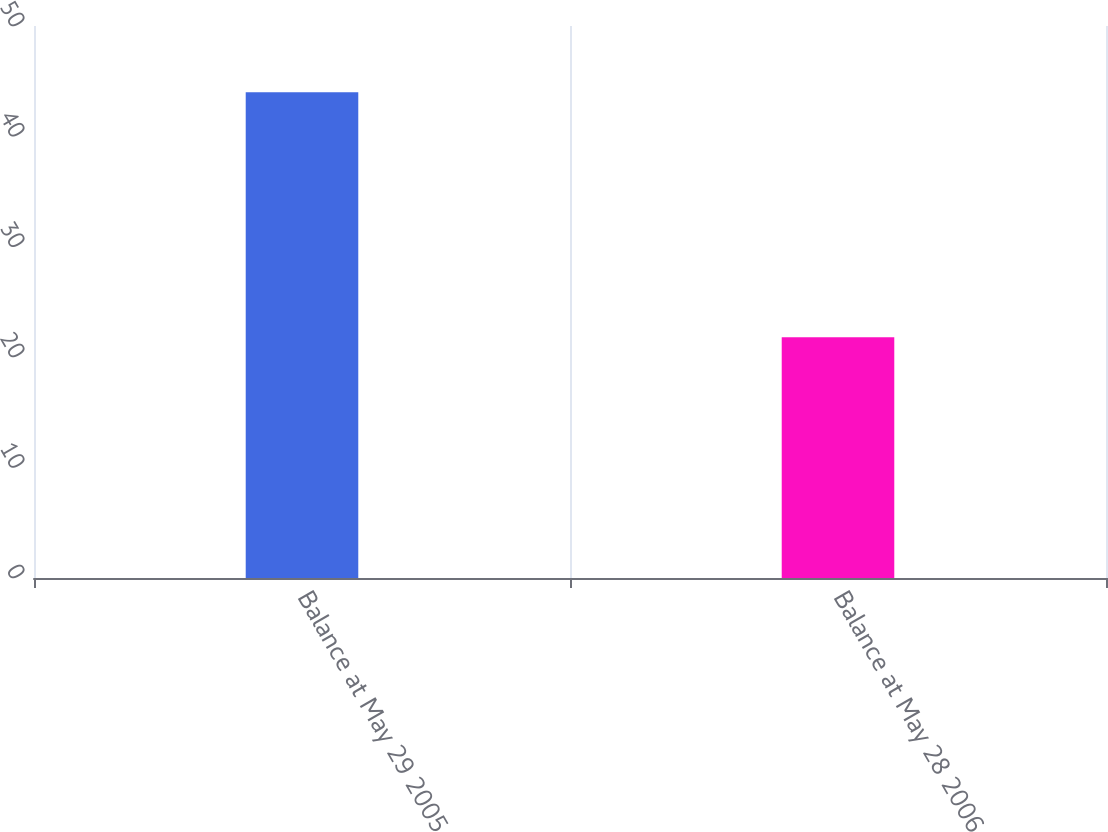Convert chart to OTSL. <chart><loc_0><loc_0><loc_500><loc_500><bar_chart><fcel>Balance at May 29 2005<fcel>Balance at May 28 2006<nl><fcel>44<fcel>21.8<nl></chart> 